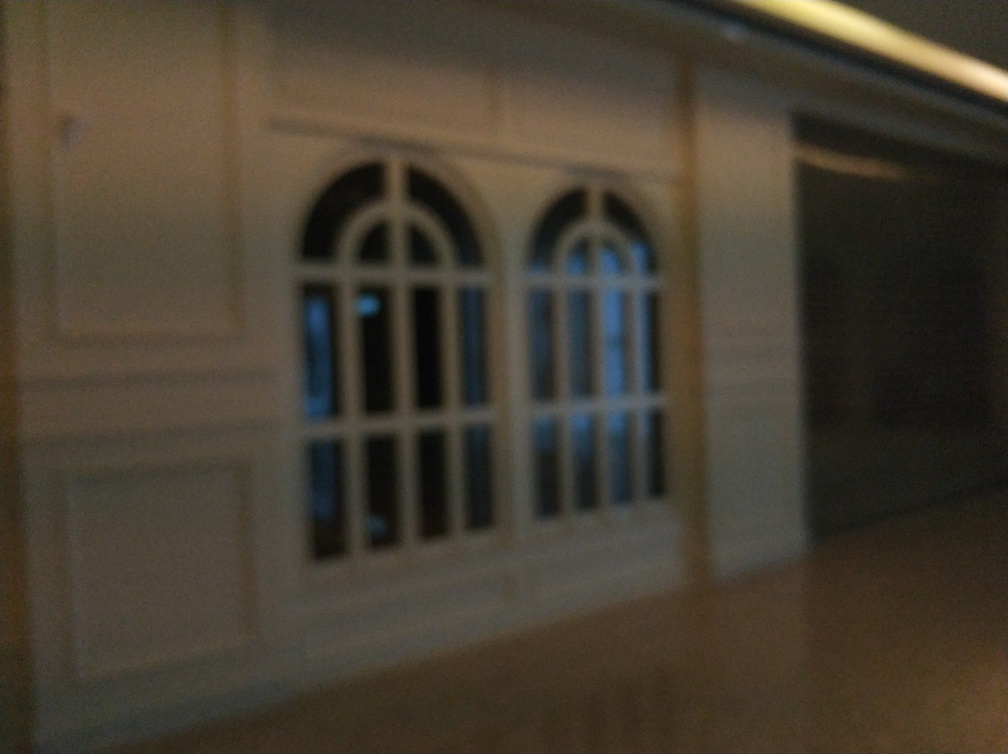Could you suggest how this image might be used in a creative project? Certainly, despite the blurriness, this image could evoke a sense of mystery or suspense in a creative project. It could serve as a background for a noir-style graphic novel panel or be incorporated into a multimedia art piece to explore themes of perception and clarity. 